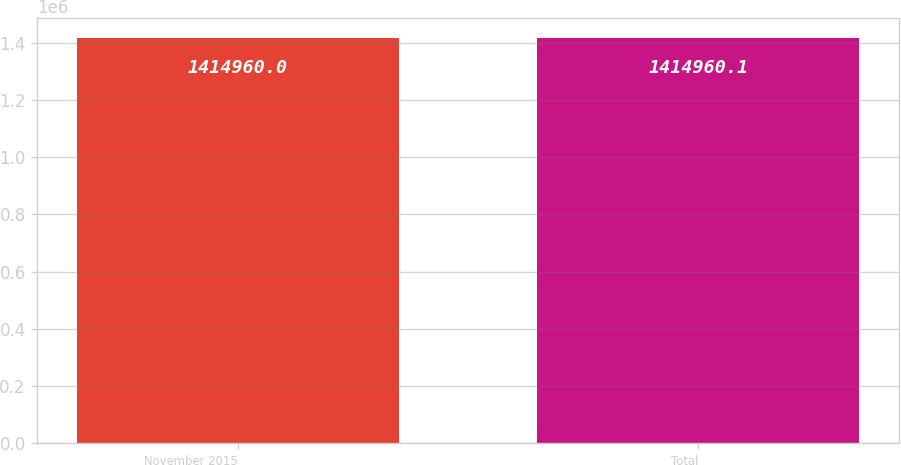<chart> <loc_0><loc_0><loc_500><loc_500><bar_chart><fcel>November 2015<fcel>Total<nl><fcel>1.41496e+06<fcel>1.41496e+06<nl></chart> 